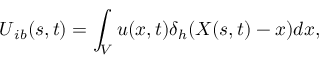Convert formula to latex. <formula><loc_0><loc_0><loc_500><loc_500>U _ { i b } ( s , t ) = \int _ { V } u ( x , t ) \delta _ { h } ( X ( s , t ) - x ) d x ,</formula> 